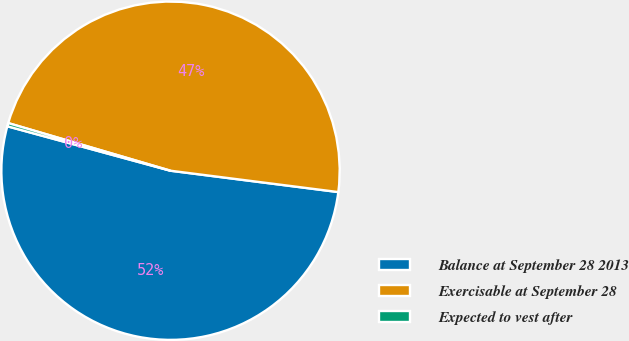Convert chart to OTSL. <chart><loc_0><loc_0><loc_500><loc_500><pie_chart><fcel>Balance at September 28 2013<fcel>Exercisable at September 28<fcel>Expected to vest after<nl><fcel>52.22%<fcel>47.47%<fcel>0.31%<nl></chart> 